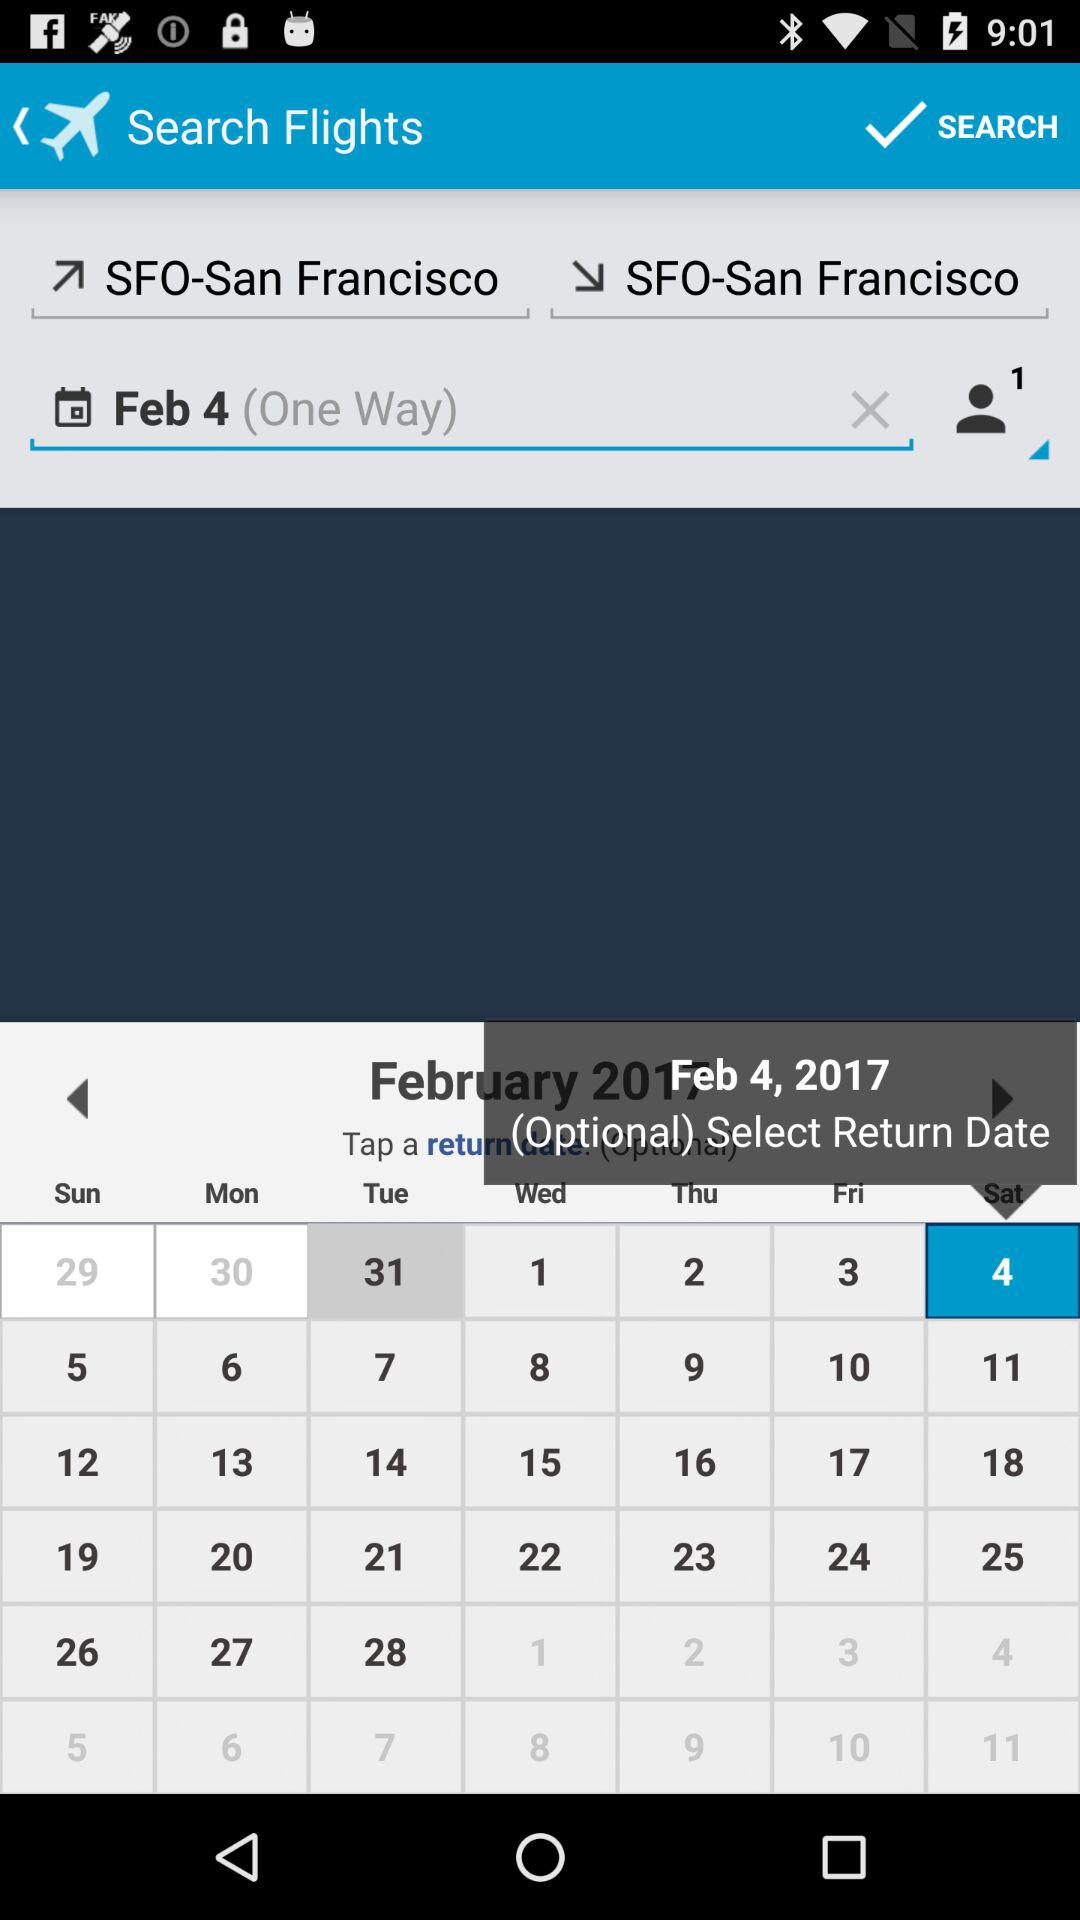What is the day on scheduled date of the journey? The day is Saturday. 